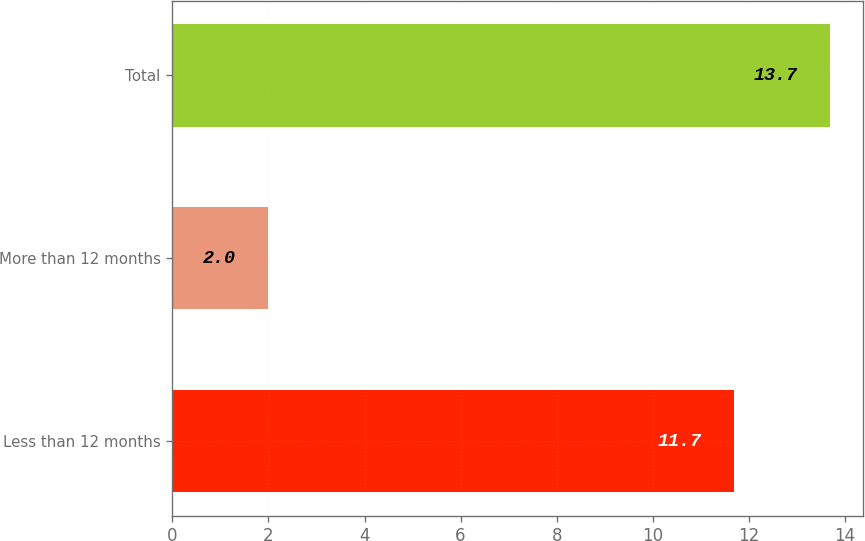Convert chart. <chart><loc_0><loc_0><loc_500><loc_500><bar_chart><fcel>Less than 12 months<fcel>More than 12 months<fcel>Total<nl><fcel>11.7<fcel>2<fcel>13.7<nl></chart> 